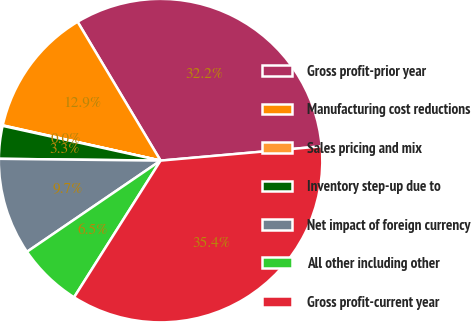Convert chart to OTSL. <chart><loc_0><loc_0><loc_500><loc_500><pie_chart><fcel>Gross profit-prior year<fcel>Manufacturing cost reductions<fcel>Sales pricing and mix<fcel>Inventory step-up due to<fcel>Net impact of foreign currency<fcel>All other including other<fcel>Gross profit-current year<nl><fcel>32.17%<fcel>12.93%<fcel>0.05%<fcel>3.27%<fcel>9.71%<fcel>6.49%<fcel>35.39%<nl></chart> 